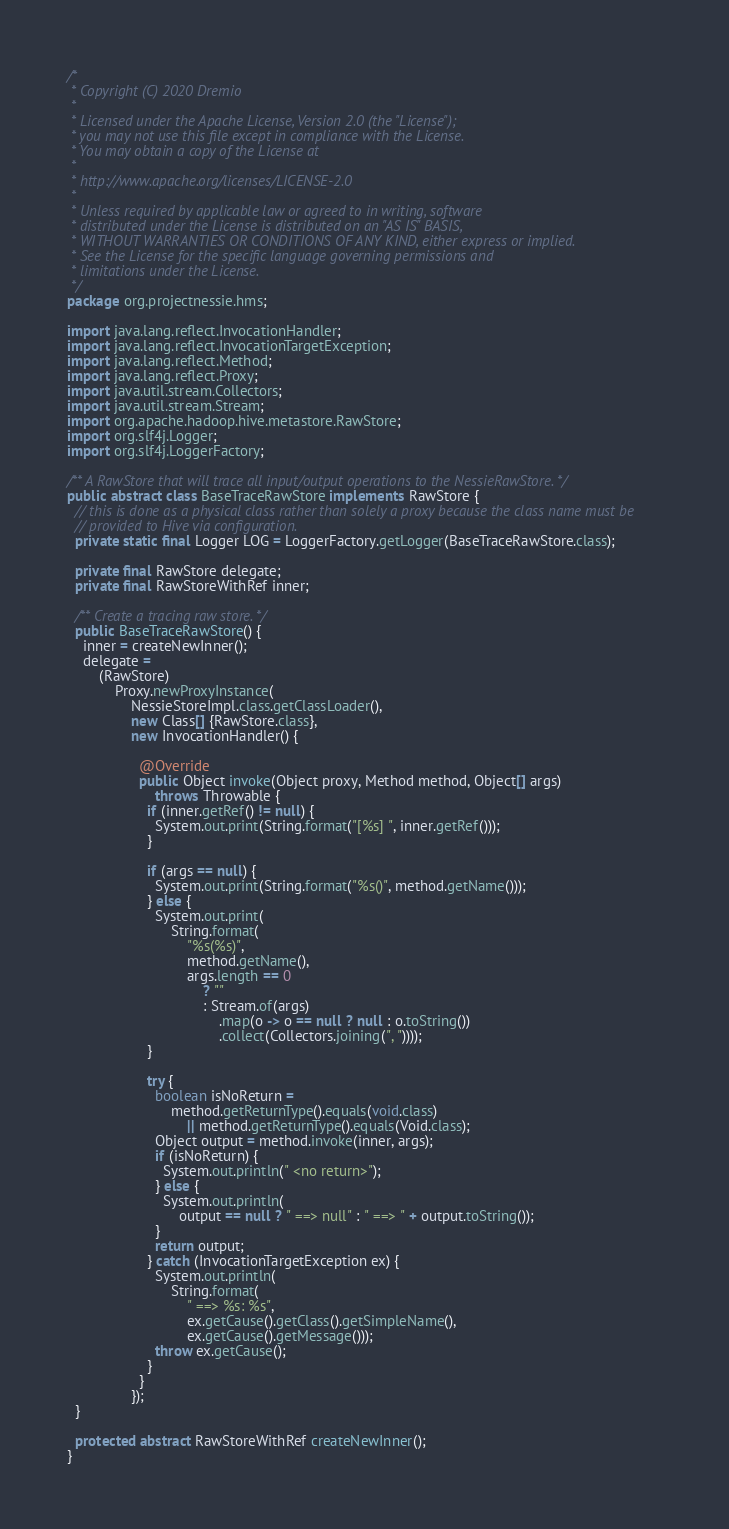<code> <loc_0><loc_0><loc_500><loc_500><_Java_>/*
 * Copyright (C) 2020 Dremio
 *
 * Licensed under the Apache License, Version 2.0 (the "License");
 * you may not use this file except in compliance with the License.
 * You may obtain a copy of the License at
 *
 * http://www.apache.org/licenses/LICENSE-2.0
 *
 * Unless required by applicable law or agreed to in writing, software
 * distributed under the License is distributed on an "AS IS" BASIS,
 * WITHOUT WARRANTIES OR CONDITIONS OF ANY KIND, either express or implied.
 * See the License for the specific language governing permissions and
 * limitations under the License.
 */
package org.projectnessie.hms;

import java.lang.reflect.InvocationHandler;
import java.lang.reflect.InvocationTargetException;
import java.lang.reflect.Method;
import java.lang.reflect.Proxy;
import java.util.stream.Collectors;
import java.util.stream.Stream;
import org.apache.hadoop.hive.metastore.RawStore;
import org.slf4j.Logger;
import org.slf4j.LoggerFactory;

/** A RawStore that will trace all input/output operations to the NessieRawStore. */
public abstract class BaseTraceRawStore implements RawStore {
  // this is done as a physical class rather than solely a proxy because the class name must be
  // provided to Hive via configuration.
  private static final Logger LOG = LoggerFactory.getLogger(BaseTraceRawStore.class);

  private final RawStore delegate;
  private final RawStoreWithRef inner;

  /** Create a tracing raw store. */
  public BaseTraceRawStore() {
    inner = createNewInner();
    delegate =
        (RawStore)
            Proxy.newProxyInstance(
                NessieStoreImpl.class.getClassLoader(),
                new Class[] {RawStore.class},
                new InvocationHandler() {

                  @Override
                  public Object invoke(Object proxy, Method method, Object[] args)
                      throws Throwable {
                    if (inner.getRef() != null) {
                      System.out.print(String.format("[%s] ", inner.getRef()));
                    }

                    if (args == null) {
                      System.out.print(String.format("%s()", method.getName()));
                    } else {
                      System.out.print(
                          String.format(
                              "%s(%s)",
                              method.getName(),
                              args.length == 0
                                  ? ""
                                  : Stream.of(args)
                                      .map(o -> o == null ? null : o.toString())
                                      .collect(Collectors.joining(", "))));
                    }

                    try {
                      boolean isNoReturn =
                          method.getReturnType().equals(void.class)
                              || method.getReturnType().equals(Void.class);
                      Object output = method.invoke(inner, args);
                      if (isNoReturn) {
                        System.out.println(" <no return>");
                      } else {
                        System.out.println(
                            output == null ? " ==> null" : " ==> " + output.toString());
                      }
                      return output;
                    } catch (InvocationTargetException ex) {
                      System.out.println(
                          String.format(
                              " ==> %s: %s",
                              ex.getCause().getClass().getSimpleName(),
                              ex.getCause().getMessage()));
                      throw ex.getCause();
                    }
                  }
                });
  }

  protected abstract RawStoreWithRef createNewInner();
}
</code> 